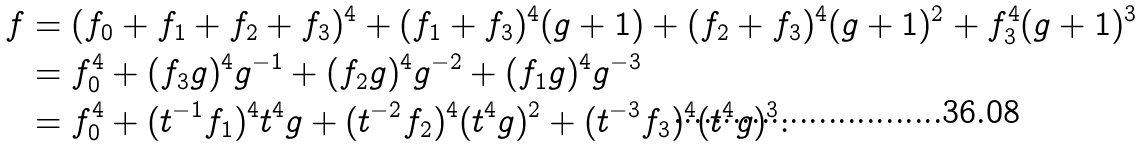<formula> <loc_0><loc_0><loc_500><loc_500>f & = ( f _ { 0 } + f _ { 1 } + f _ { 2 } + f _ { 3 } ) ^ { 4 } + ( f _ { 1 } + f _ { 3 } ) ^ { 4 } ( g + 1 ) + ( f _ { 2 } + f _ { 3 } ) ^ { 4 } ( g + 1 ) ^ { 2 } + f _ { 3 } ^ { 4 } ( g + 1 ) ^ { 3 } \\ & = f _ { 0 } ^ { 4 } + ( f _ { 3 } g ) ^ { 4 } g ^ { - 1 } + ( f _ { 2 } g ) ^ { 4 } g ^ { - 2 } + ( f _ { 1 } g ) ^ { 4 } g ^ { - 3 } \\ & = f _ { 0 } ^ { 4 } + ( t ^ { - 1 } f _ { 1 } ) ^ { 4 } t ^ { 4 } g + ( t ^ { - 2 } f _ { 2 } ) ^ { 4 } ( t ^ { 4 } g ) ^ { 2 } + ( t ^ { - 3 } f _ { 3 } ) ^ { 4 } ( t ^ { 4 } g ) ^ { 3 } .</formula> 